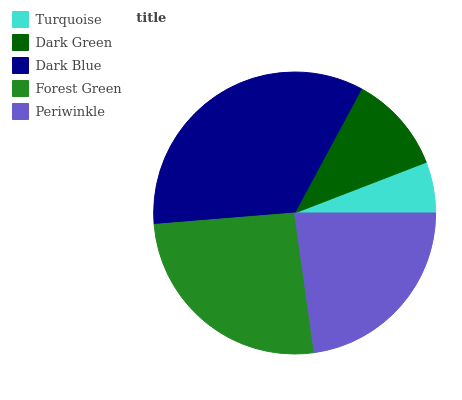Is Turquoise the minimum?
Answer yes or no. Yes. Is Dark Blue the maximum?
Answer yes or no. Yes. Is Dark Green the minimum?
Answer yes or no. No. Is Dark Green the maximum?
Answer yes or no. No. Is Dark Green greater than Turquoise?
Answer yes or no. Yes. Is Turquoise less than Dark Green?
Answer yes or no. Yes. Is Turquoise greater than Dark Green?
Answer yes or no. No. Is Dark Green less than Turquoise?
Answer yes or no. No. Is Periwinkle the high median?
Answer yes or no. Yes. Is Periwinkle the low median?
Answer yes or no. Yes. Is Dark Blue the high median?
Answer yes or no. No. Is Dark Green the low median?
Answer yes or no. No. 